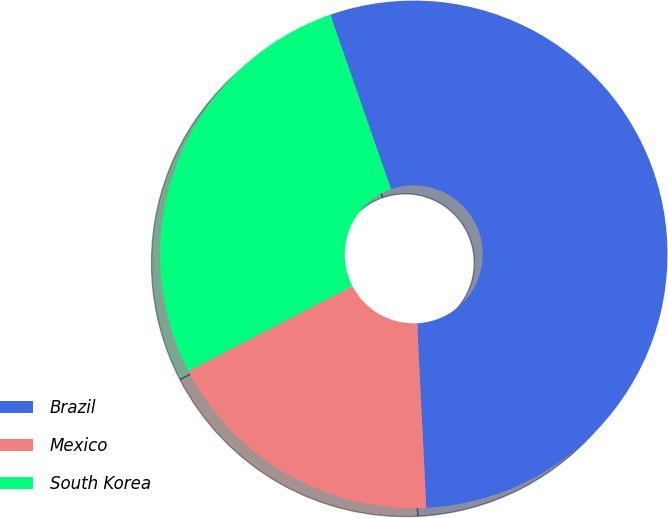<chart> <loc_0><loc_0><loc_500><loc_500><pie_chart><fcel>Brazil<fcel>Mexico<fcel>South Korea<nl><fcel>54.55%<fcel>18.18%<fcel>27.27%<nl></chart> 